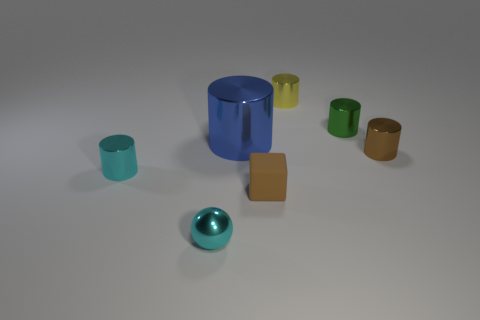Subtract all small cyan cylinders. How many cylinders are left? 4 Subtract 3 cylinders. How many cylinders are left? 2 Subtract all brown cylinders. How many cylinders are left? 4 Add 3 cyan things. How many objects exist? 10 Subtract all brown cylinders. Subtract all yellow blocks. How many cylinders are left? 4 Add 5 cyan things. How many cyan things are left? 7 Add 1 green metal cylinders. How many green metal cylinders exist? 2 Subtract 1 green cylinders. How many objects are left? 6 Subtract all spheres. How many objects are left? 6 Subtract all small red objects. Subtract all tiny balls. How many objects are left? 6 